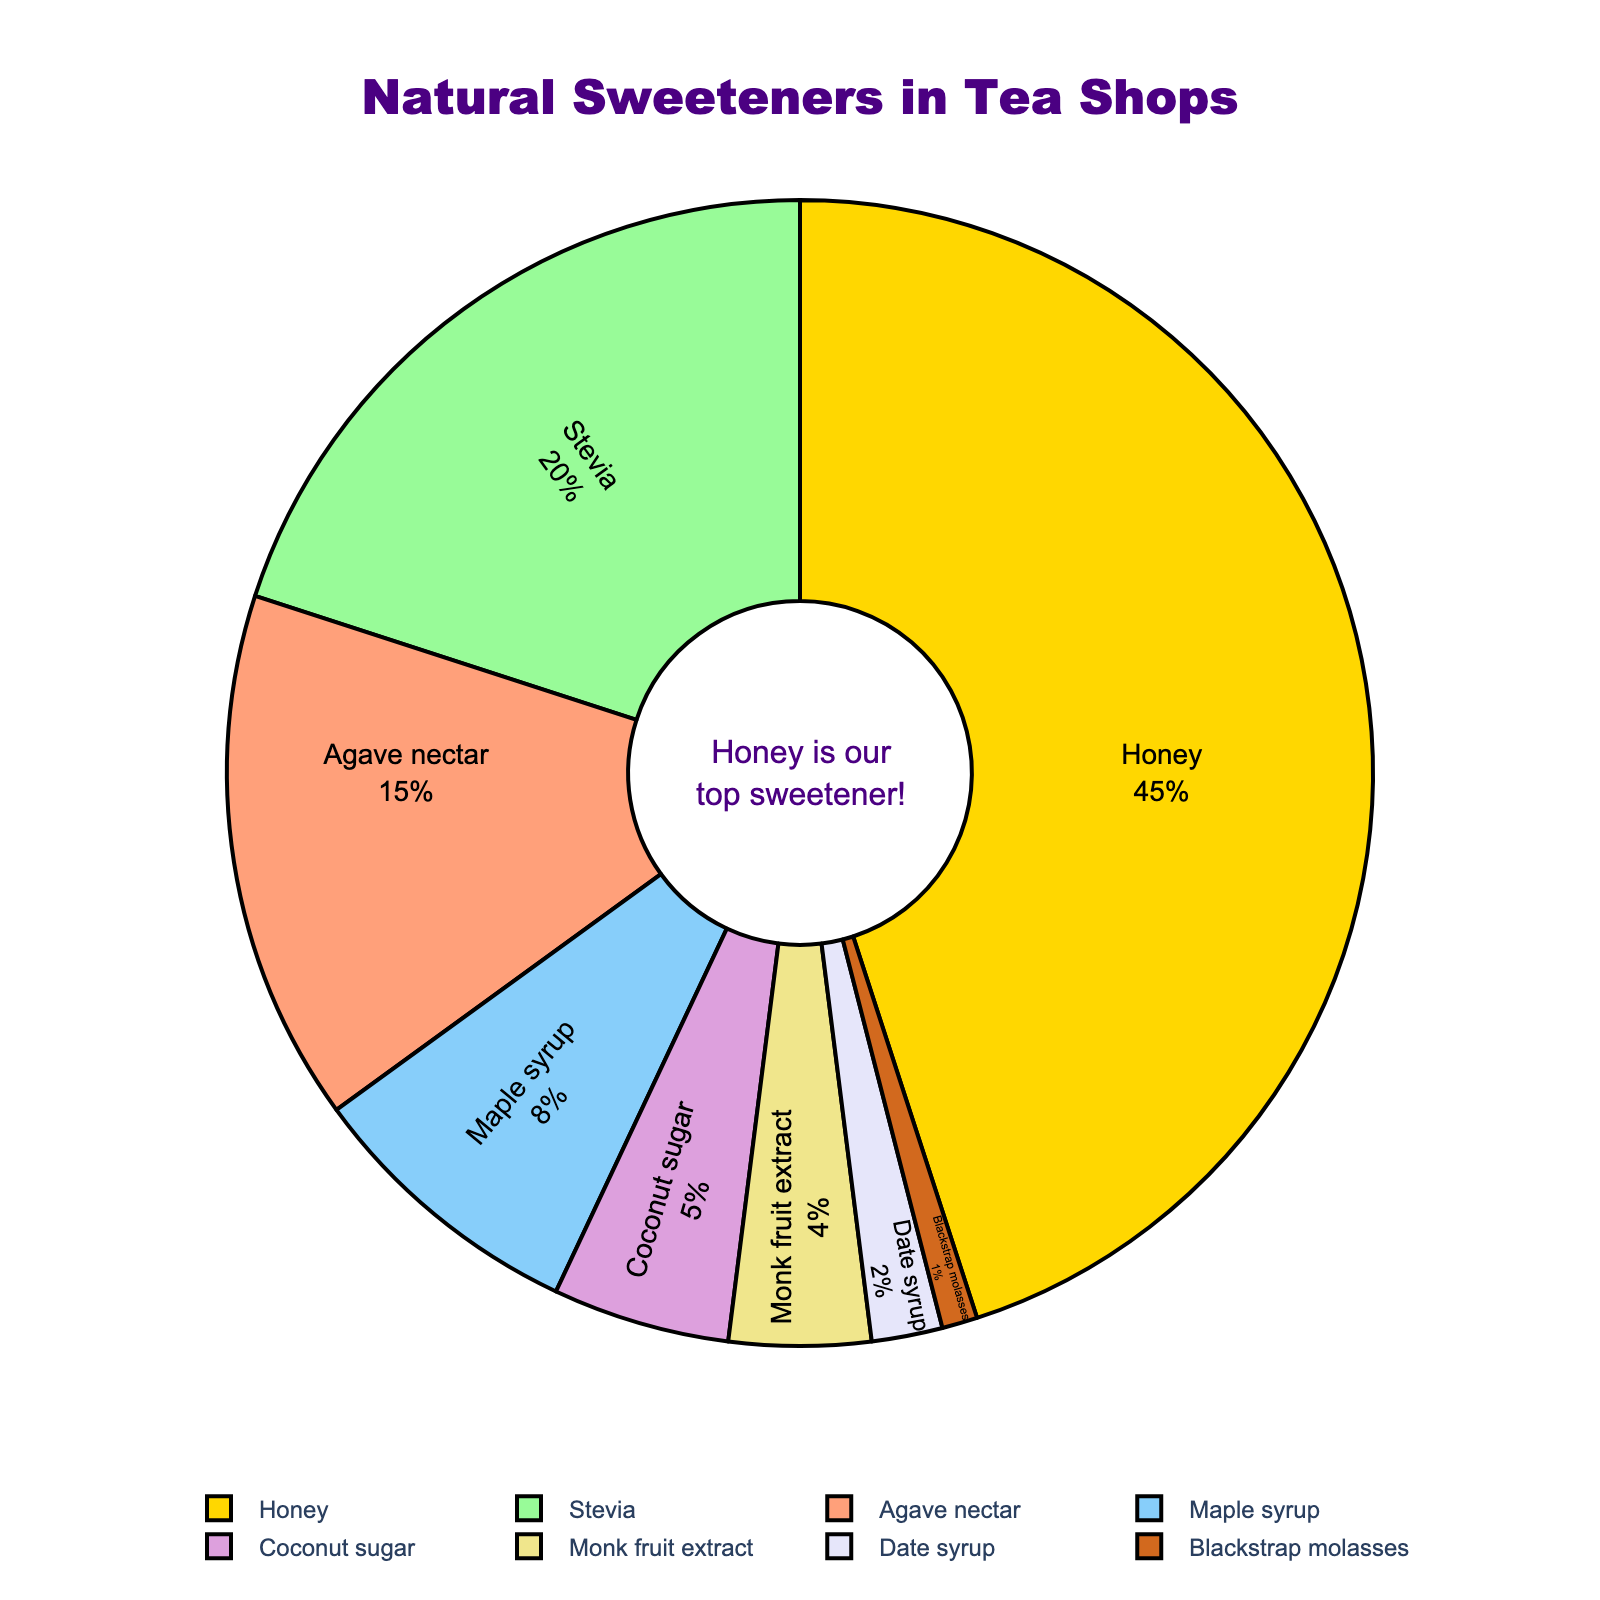What's the sweetener with the highest percentage used in tea shops? By observing the figure, one can see that the sweetener labeled "Honey" occupies the largest section of the pie chart. Hence, honey has the highest percentage.
Answer: Honey How much more popular is honey compared to stevia? The pie chart shows that honey has a 45% share and stevia has a 20% share. To find the difference, subtract stevia's percentage from honey's percentage: 45% - 20% = 25%.
Answer: 25% What percentage of sweeteners used are not honey? Honey occupies 45% of the pie chart. To find the percentage of sweeteners that are not honey, subtract honey's percentage from 100%: 100% - 45% = 55%.
Answer: 55% Which sweetener is used the least, and what is its percentage? From the pie chart, the smallest section corresponds to "Blackstrap molasses," which has a 1% share.
Answer: Blackstrap molasses, 1% What is the total percentage of sweeteners that are used less than 10% each? The sweeteners with less than 10% are maple syrup (8%), coconut sugar (5%), monk fruit extract (4%), date syrup (2%), and blackstrap molasses (1%). Adding these percentages: 8% + 5% + 4% + 2% + 1% = 20%.
Answer: 20% How do agave nectar and maple syrup compare in terms of their percentage usage? According to the pie chart, agave nectar has a 15% share, and maple syrup has an 8% share. Agave nectar is more popular than maple syrup by a difference of 15% - 8% = 7%.
Answer: Agave nectar is more popular by 7% What is the combined percentage of stevia and monk fruit extract? The pie chart shows stevia with a 20% share and monk fruit extract with a 4% share. Adding these percentages: 20% + 4% = 24%.
Answer: 24% Which two sweeteners together make up 30% of the overall usage? From the pie chart, stevia (20%) and agave nectar (15%) together make up more than 30%. The combination of maple syrup (8%) and coconut sugar (5%) is too low. The correct combination is stevia (20%) and monk fruit extract (4%) plus coconut sugar (5%): 20% + 5% + 4% = 29%, the nearest combination.
Answer: Stevia and monk fruit extract and coconut sugar What is the difference in percentage between the highest and lowest used sweeteners? The highest percentage is honey with 45%, and the lowest is blackstrap molasses with 1%. The difference is obtained by subtracting the lowest from the highest: 45% - 1% = 44%.
Answer: 44% Which sweeteners have a usage percentage that is greater than 10% but less than 25%? The pie chart shows stevia with 20% and agave nectar with 15%. These percentages fall between 10% and 25%.
Answer: Stevia and agave nectar 